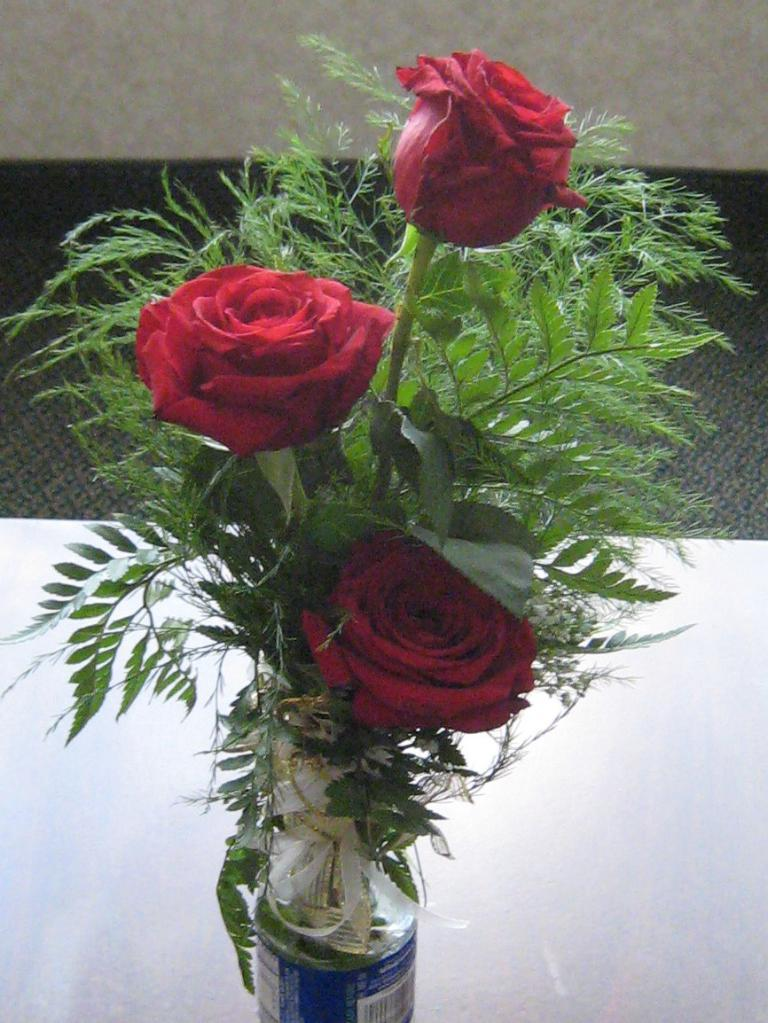What is the main object in the middle of the image? There is a flower pot in the middle of the image. What type of flowers are in the flower pot? There are three red roses in the flower pot. What type of polish is being applied to the roses in the image? There is no polish being applied to the roses in the image; they are simply red roses in a flower pot. 